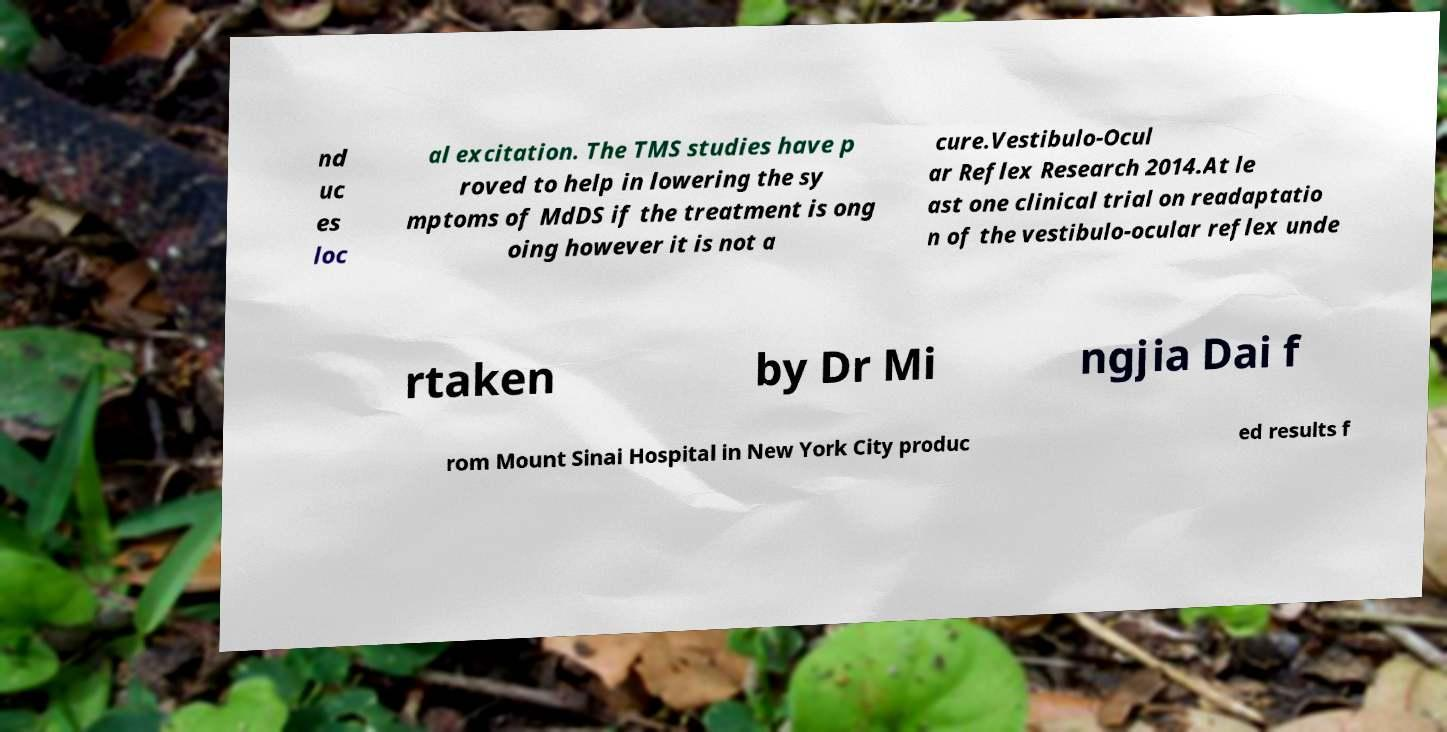Can you read and provide the text displayed in the image?This photo seems to have some interesting text. Can you extract and type it out for me? nd uc es loc al excitation. The TMS studies have p roved to help in lowering the sy mptoms of MdDS if the treatment is ong oing however it is not a cure.Vestibulo-Ocul ar Reflex Research 2014.At le ast one clinical trial on readaptatio n of the vestibulo-ocular reflex unde rtaken by Dr Mi ngjia Dai f rom Mount Sinai Hospital in New York City produc ed results f 